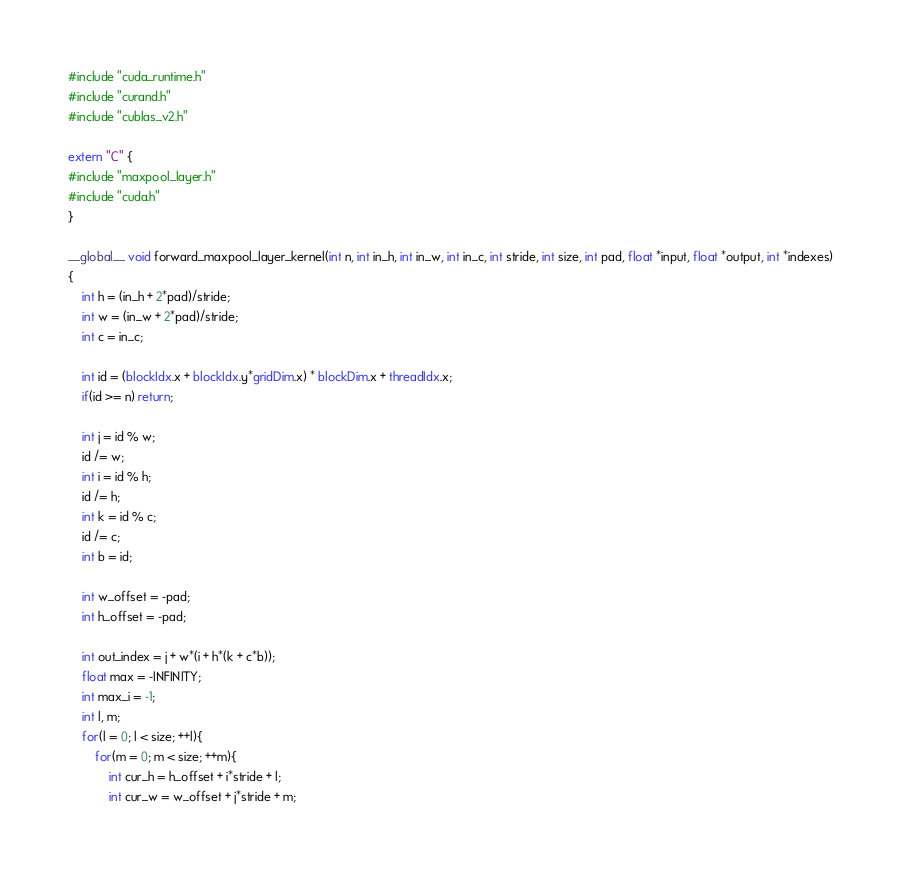Convert code to text. <code><loc_0><loc_0><loc_500><loc_500><_Cuda_>#include "cuda_runtime.h"
#include "curand.h"
#include "cublas_v2.h"

extern "C" {
#include "maxpool_layer.h"
#include "cuda.h"
}

__global__ void forward_maxpool_layer_kernel(int n, int in_h, int in_w, int in_c, int stride, int size, int pad, float *input, float *output, int *indexes)
{
    int h = (in_h + 2*pad)/stride;
    int w = (in_w + 2*pad)/stride;
    int c = in_c;

    int id = (blockIdx.x + blockIdx.y*gridDim.x) * blockDim.x + threadIdx.x;
    if(id >= n) return;

    int j = id % w;
    id /= w;
    int i = id % h;
    id /= h;
    int k = id % c;
    id /= c;
    int b = id;

    int w_offset = -pad;
    int h_offset = -pad;

    int out_index = j + w*(i + h*(k + c*b));
    float max = -INFINITY;
    int max_i = -1;
    int l, m;
    for(l = 0; l < size; ++l){
        for(m = 0; m < size; ++m){
            int cur_h = h_offset + i*stride + l;
            int cur_w = w_offset + j*stride + m;</code> 